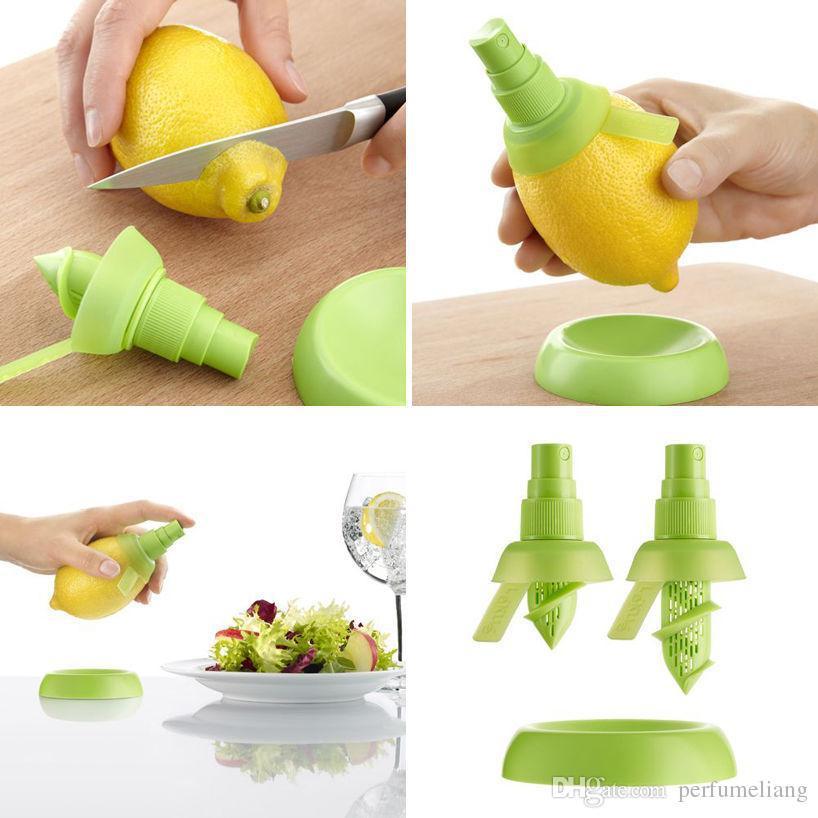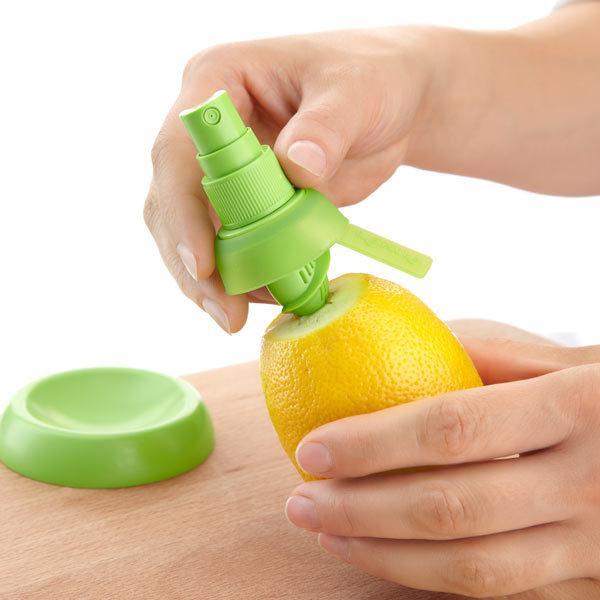The first image is the image on the left, the second image is the image on the right. Given the left and right images, does the statement "In one of the images, a whole lemon is being cut with a knife." hold true? Answer yes or no. Yes. The first image is the image on the left, the second image is the image on the right. Evaluate the accuracy of this statement regarding the images: "An image contains a lemon being sliced by a knife.". Is it true? Answer yes or no. Yes. 